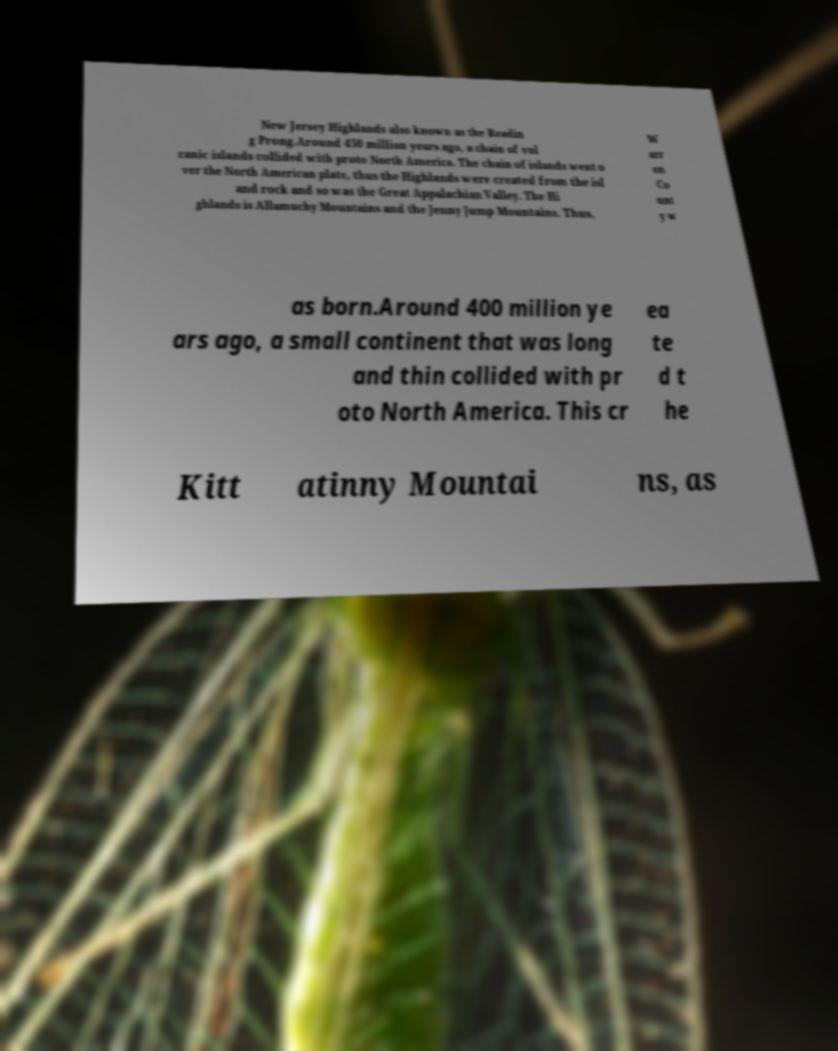I need the written content from this picture converted into text. Can you do that? New Jersey Highlands also known as the Readin g Prong.Around 450 million years ago, a chain of vol canic islands collided with proto North America. The chain of islands went o ver the North American plate, thus the Highlands were created from the isl and rock and so was the Great Appalachian Valley. The Hi ghlands is Allamuchy Mountains and the Jenny Jump Mountains. Thus, W arr en Co unt y w as born.Around 400 million ye ars ago, a small continent that was long and thin collided with pr oto North America. This cr ea te d t he Kitt atinny Mountai ns, as 